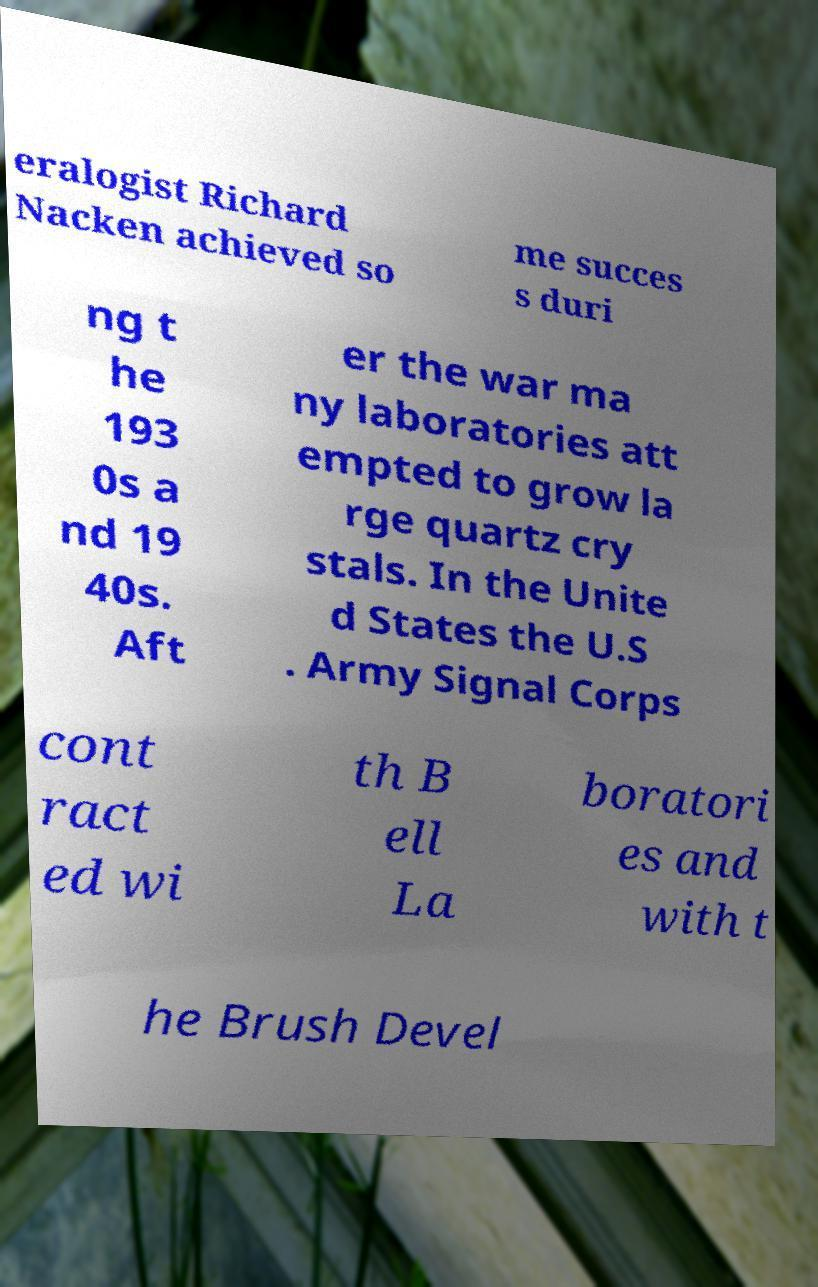Could you extract and type out the text from this image? eralogist Richard Nacken achieved so me succes s duri ng t he 193 0s a nd 19 40s. Aft er the war ma ny laboratories att empted to grow la rge quartz cry stals. In the Unite d States the U.S . Army Signal Corps cont ract ed wi th B ell La boratori es and with t he Brush Devel 